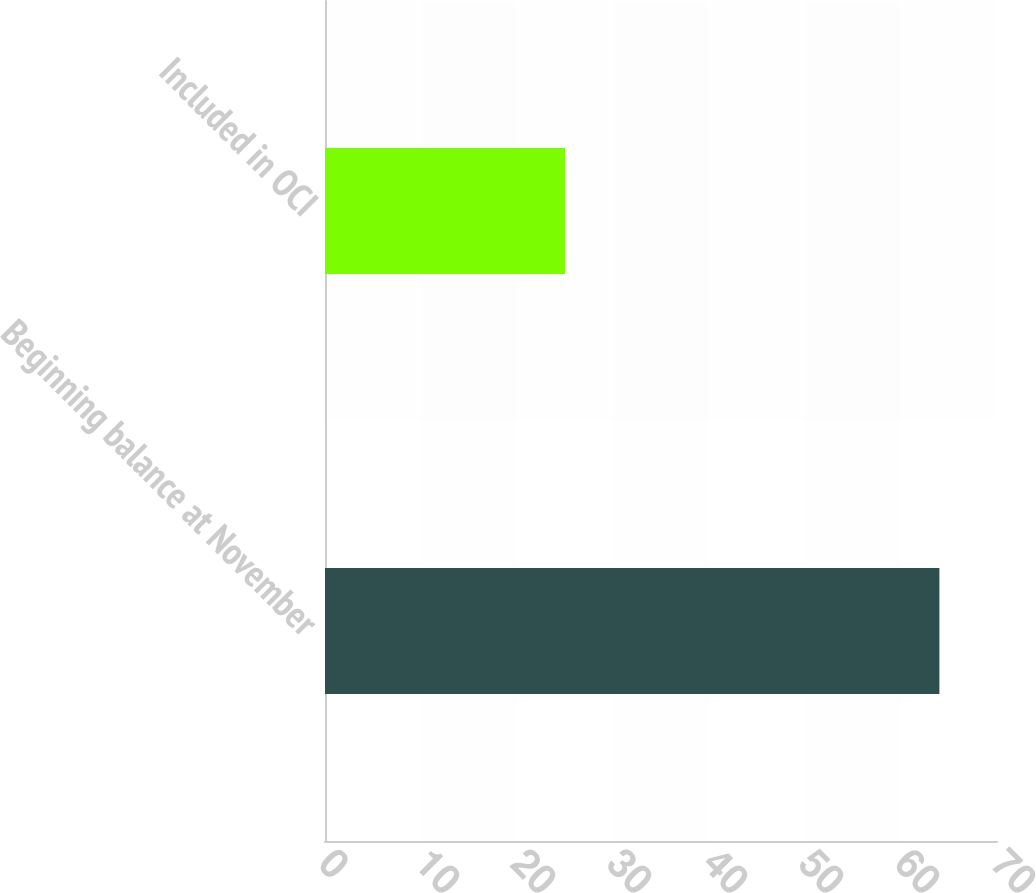<chart> <loc_0><loc_0><loc_500><loc_500><bar_chart><fcel>Beginning balance at November<fcel>Included in OCI<nl><fcel>64<fcel>25<nl></chart> 